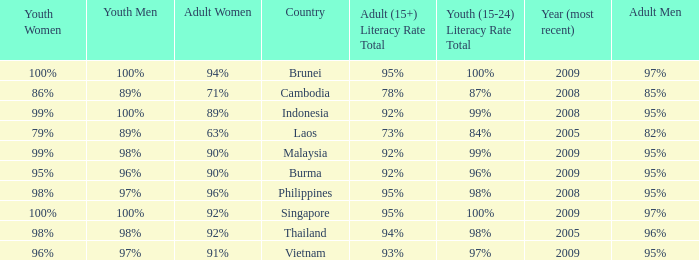What country has a Youth (15-24) Literacy Rate Total of 99%, and a Youth Men of 98%? Malaysia. 